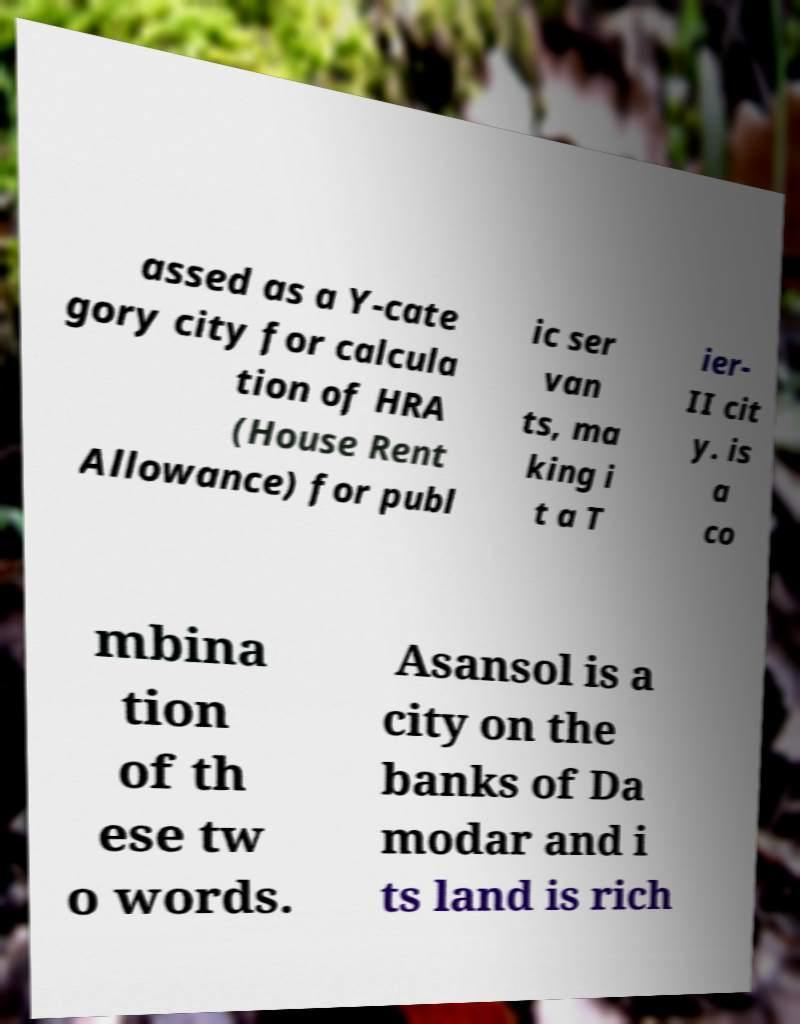What messages or text are displayed in this image? I need them in a readable, typed format. assed as a Y-cate gory city for calcula tion of HRA (House Rent Allowance) for publ ic ser van ts, ma king i t a T ier- II cit y. is a co mbina tion of th ese tw o words. Asansol is a city on the banks of Da modar and i ts land is rich 